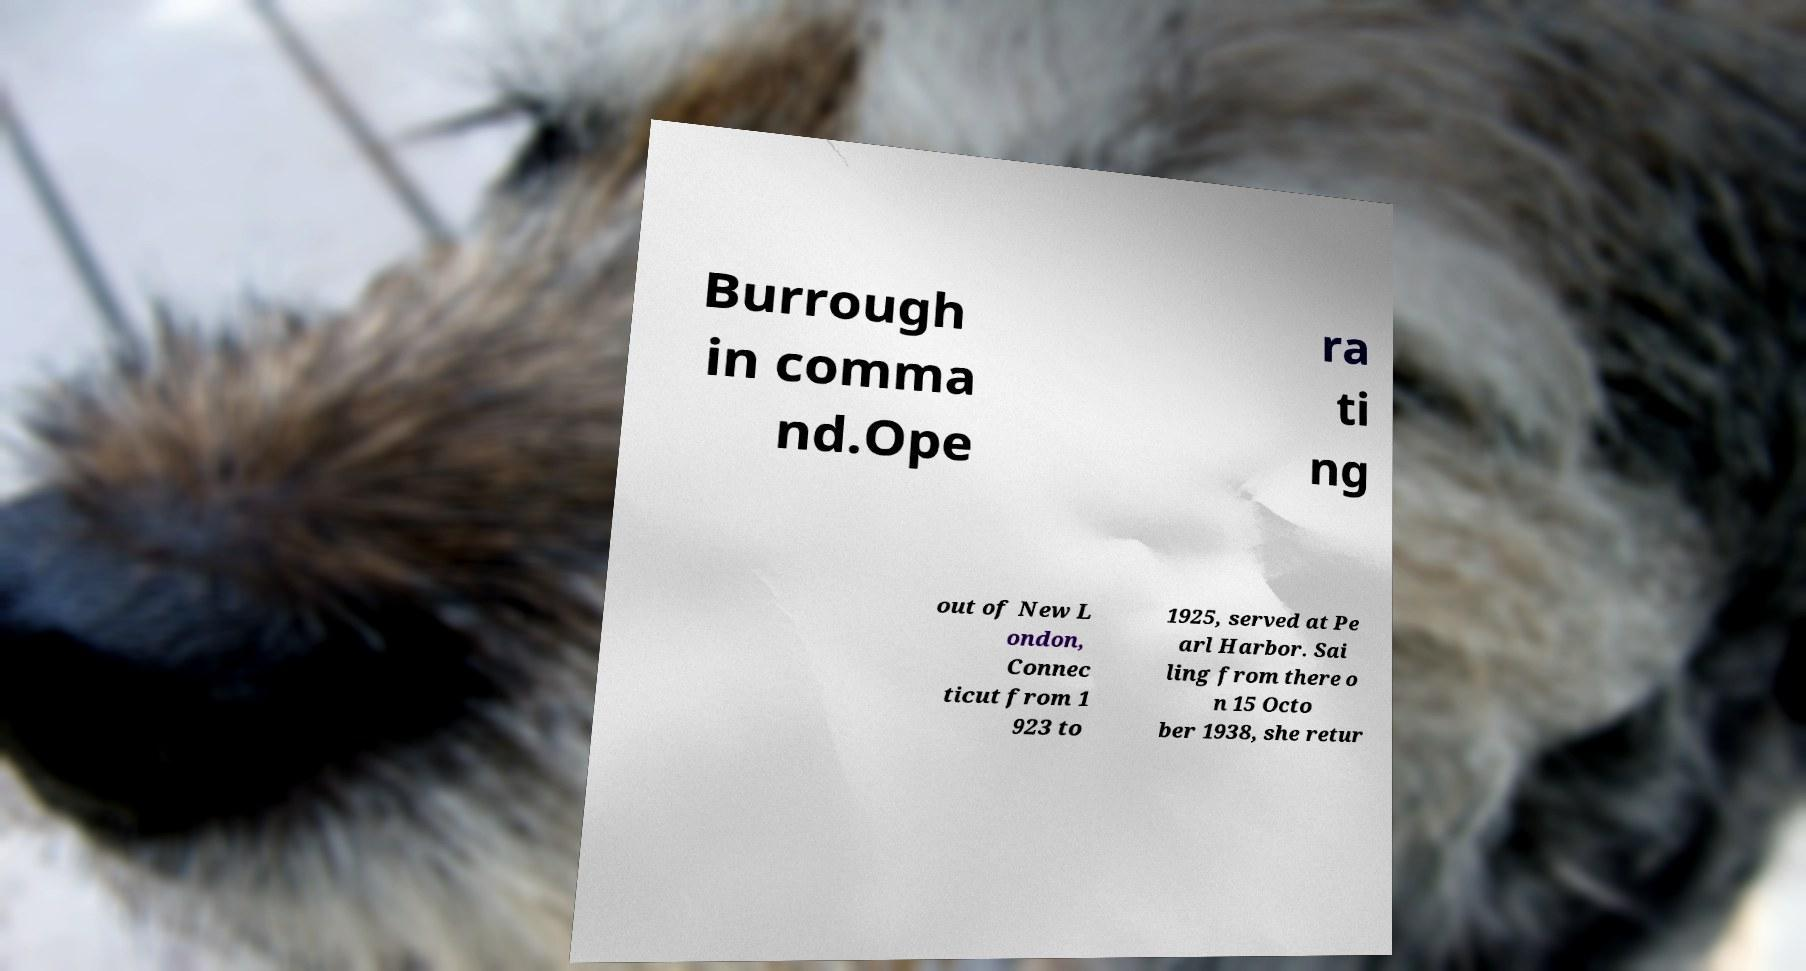I need the written content from this picture converted into text. Can you do that? Burrough in comma nd.Ope ra ti ng out of New L ondon, Connec ticut from 1 923 to 1925, served at Pe arl Harbor. Sai ling from there o n 15 Octo ber 1938, she retur 